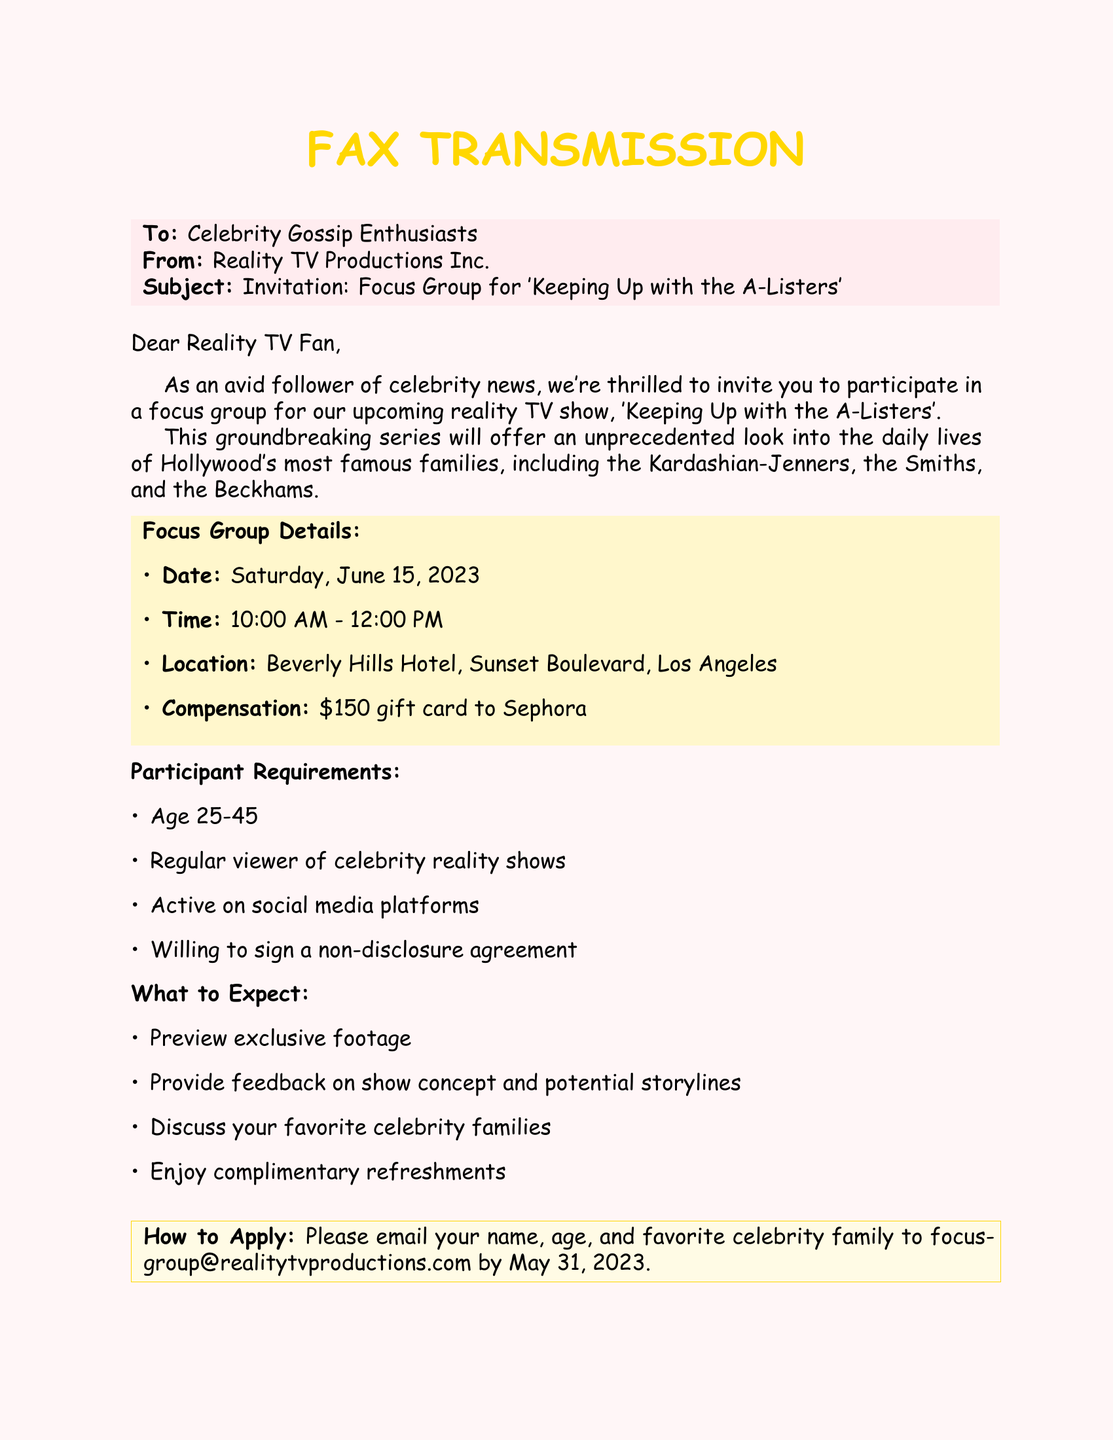What is the date of the focus group? The date for the focus group is stated clearly in the document.
Answer: Saturday, June 15, 2023 What is the location of the event? The document specifies the location for the focus group event.
Answer: Beverly Hills Hotel, Sunset Boulevard, Los Angeles How much is the compensation for participants? The document mentions the compensation amount provided to participants for attending the focus group.
Answer: $150 gift card to Sephora What is one requirement for participants? The document lists specific requirements needed to participate in the focus group.
Answer: Regular viewer of celebrity reality shows What will participants preview during the focus group? The document indicates what participants will experience during the focus group.
Answer: Exclusive footage What should participants include in their application email? The document describes what information to submit in the application email.
Answer: Name, age, and favorite celebrity family Which age group is targeted for participants? The document specifies the age range that participants must fall into.
Answer: Age 25-45 What type of refreshment will be provided at the event? The document mentions refreshments included for participants.
Answer: Complimentary refreshments 